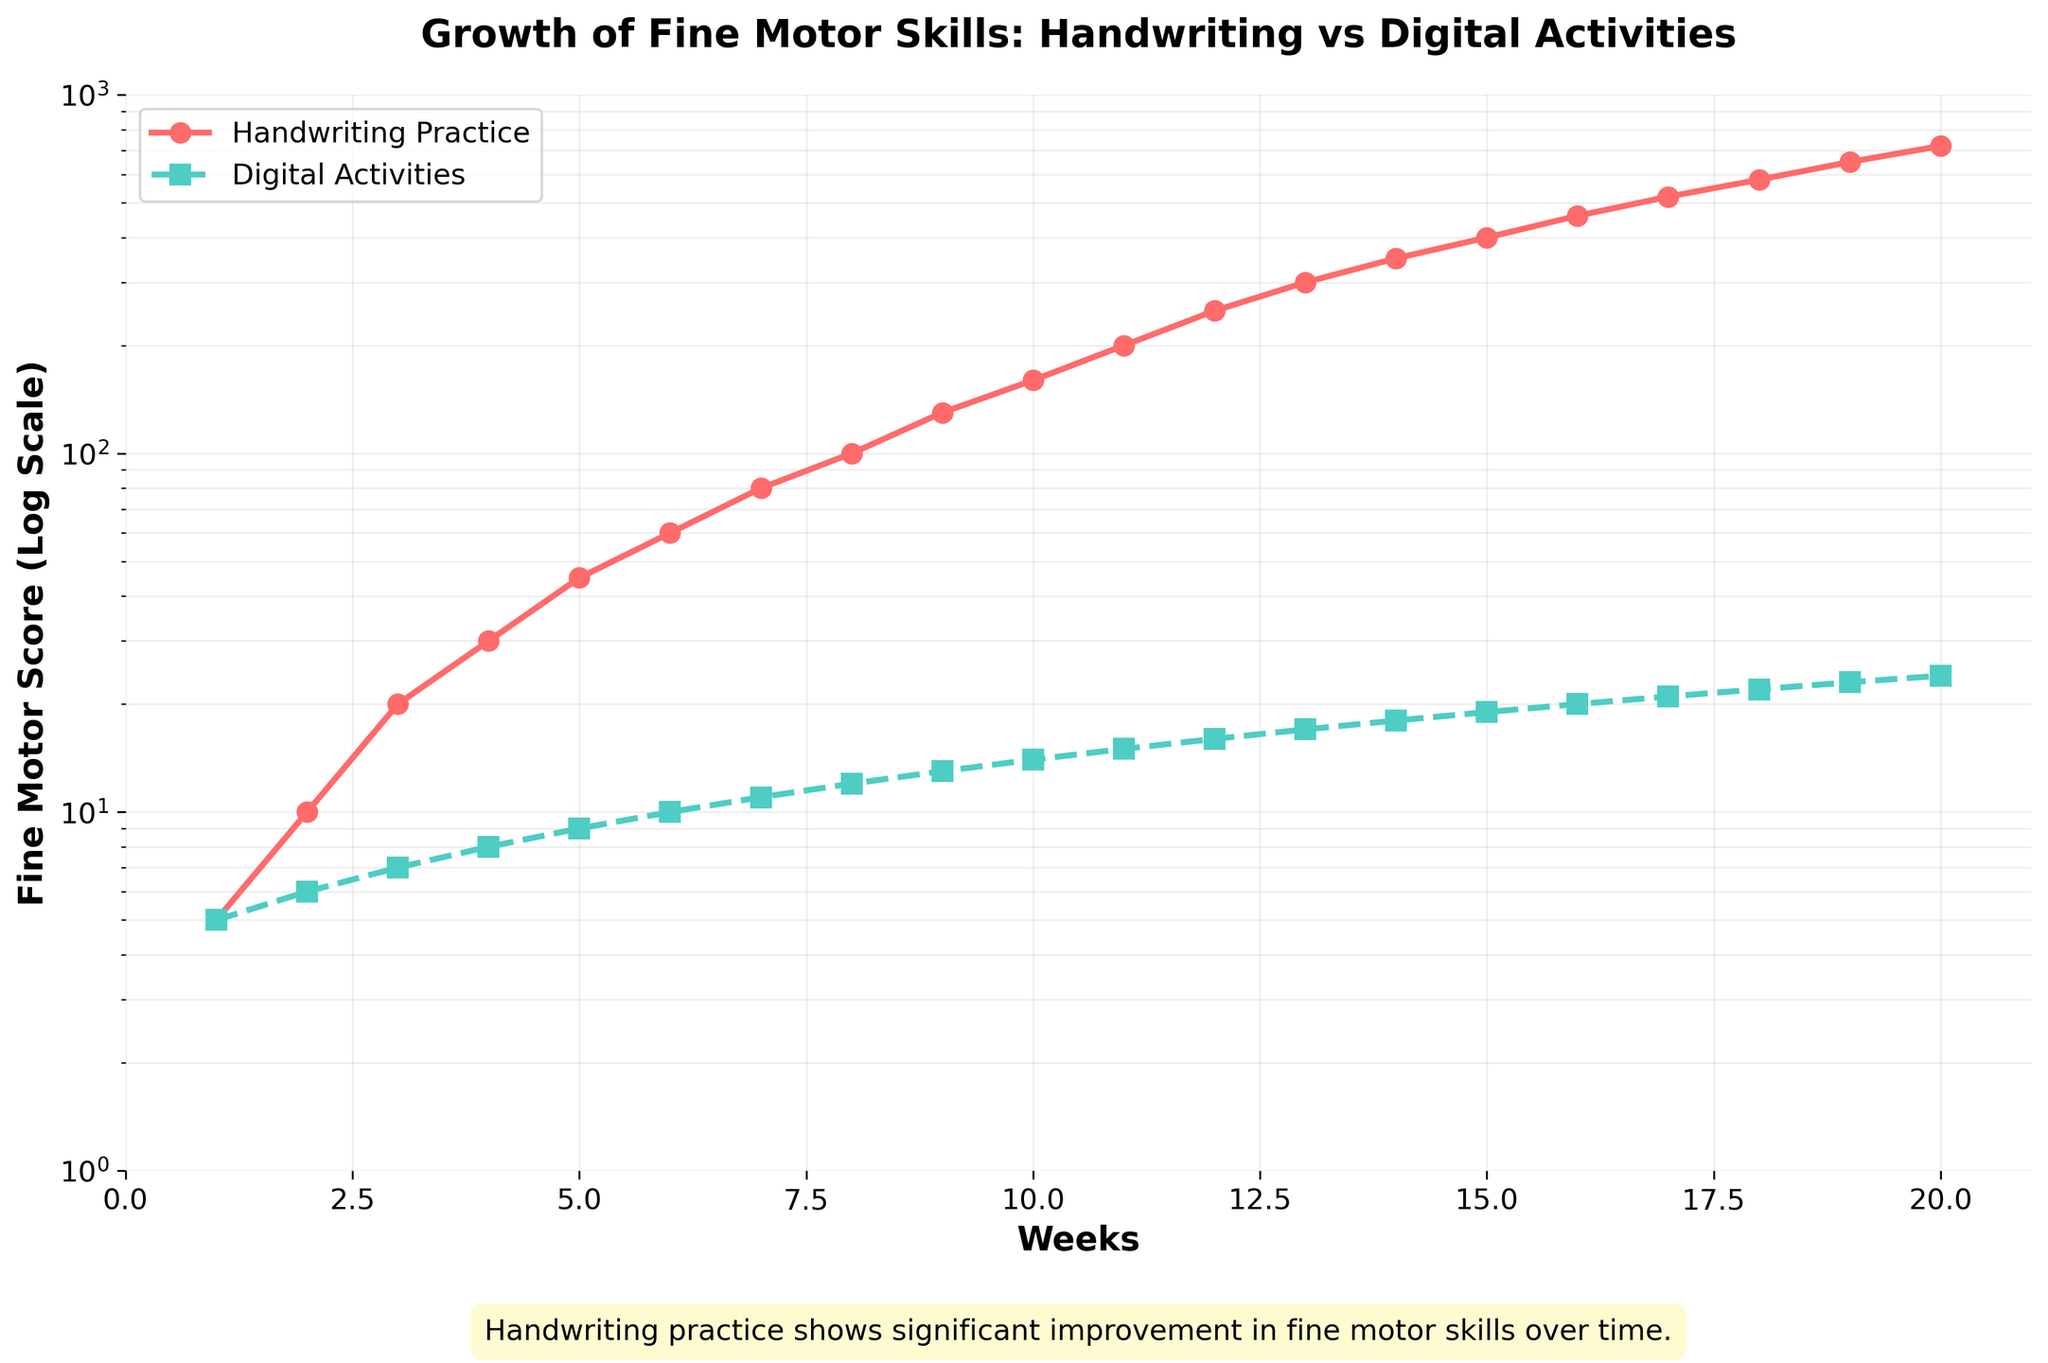What is the title of the figure? The title of the figure is located at the top of the plot and describes what the figure is about.
Answer: Growth of Fine Motor Skills: Handwriting vs Digital Activities How many weeks are there in the data? The x-axis (labeled 'Weeks') shows a range from 1 to 20, which indicates the data spans 20 weeks.
Answer: 20 Which practice results in a higher fine motor score by Week 10? By looking at the value on the y-axis at Week 10 for both lines, the higher score belongs to the red line, which represents "Handwriting Practice".
Answer: Handwriting Practice How do the fine motor scores for handwriting and digital activities compare at Week 5? At Week 5, the fine motor score for handwriting is 45, while for digital activities it is 9.
Answer: Handwriting: 45, Digital: 9 By how much does the fine motor score for handwriting practice increase between Week 1 and Week 20? For handwriting practice, the fine motor score at Week 1 is 5, and at Week 20 it is 720. The difference is 720 - 5.
Answer: 715 Which weeks show a doubling of fine motor scores for digital activities? To find the weeks where the fine motor scores double, look at the values on the turquoise line and see where each value is roughly double the previous week's value. For example, the score doubles from 6 to 12 between Week 2 and Week 8.
Answer: 6 to 12 (between Weeks 6 and 8) At what rate does the fine motor score for handwriting practice increase compared to digital activities over time? On the log scale, the fine motor score for handwriting practice follows a steeper slope, indicating a faster rate of increase compared to digital activities.
Answer: Handwriting grows faster What is the fine motor score for handwriting practice at Week 12? According to the figure, the red line (handwriting practice) at Week 12 shows a score of 250.
Answer: 250 By Week 15, what is the difference between the fine motor scores of handwriting practice and digital activities? By Week 15, the fine motor score for handwriting practice is 400, and for digital activities it is 19. The difference is 400 - 19.
Answer: 381 How does the trend of fine motor scores in digital activities appear on a log scale? The trend for digital activities on a log scale appears as a less steep, nearly linear increase compared to handwriting practice, indicating a gradual improvement.
Answer: Gradual, nearly linear increase 